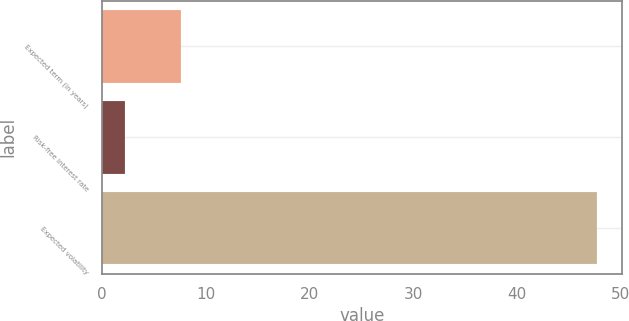<chart> <loc_0><loc_0><loc_500><loc_500><bar_chart><fcel>Expected term (in years)<fcel>Risk-free interest rate<fcel>Expected volatility<nl><fcel>7.6<fcel>2.2<fcel>47.7<nl></chart> 